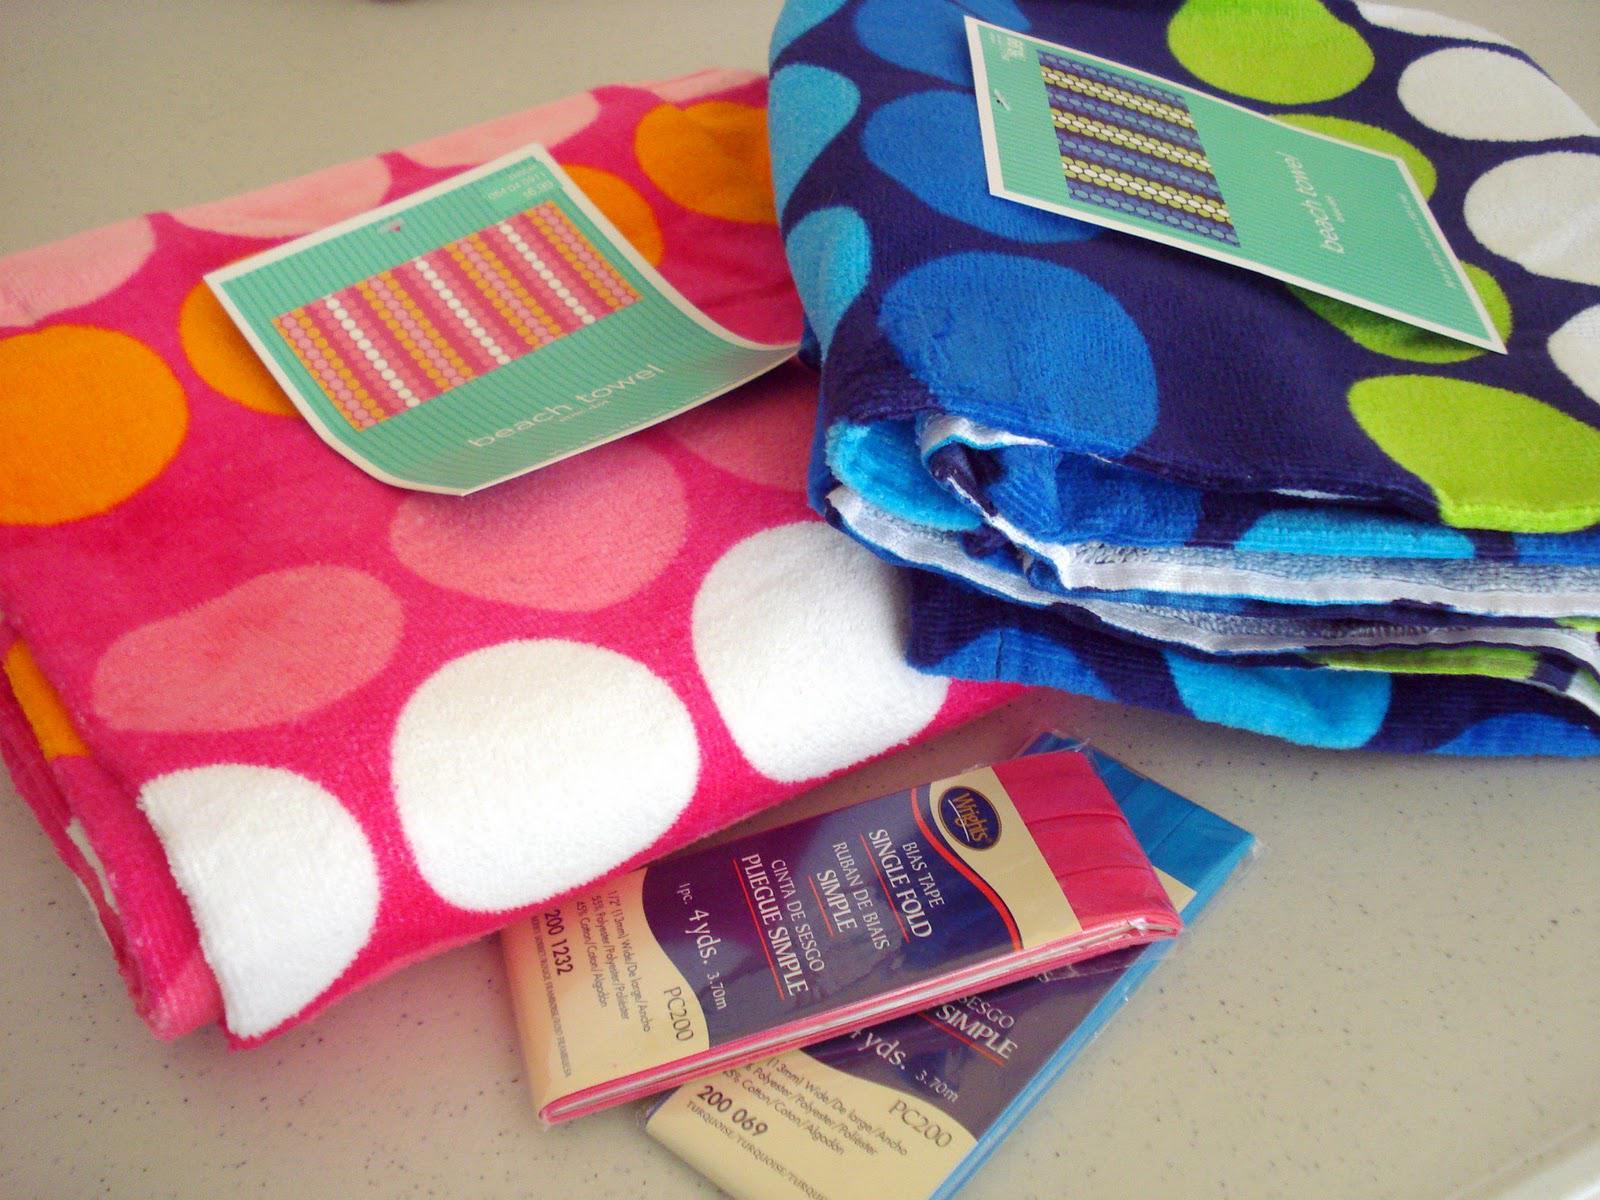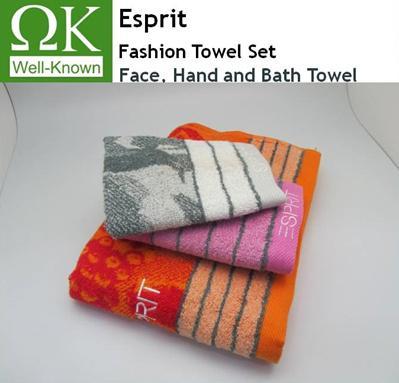The first image is the image on the left, the second image is the image on the right. Examine the images to the left and right. Is the description "One image features only solid-colored towels in varying colors." accurate? Answer yes or no. No. 